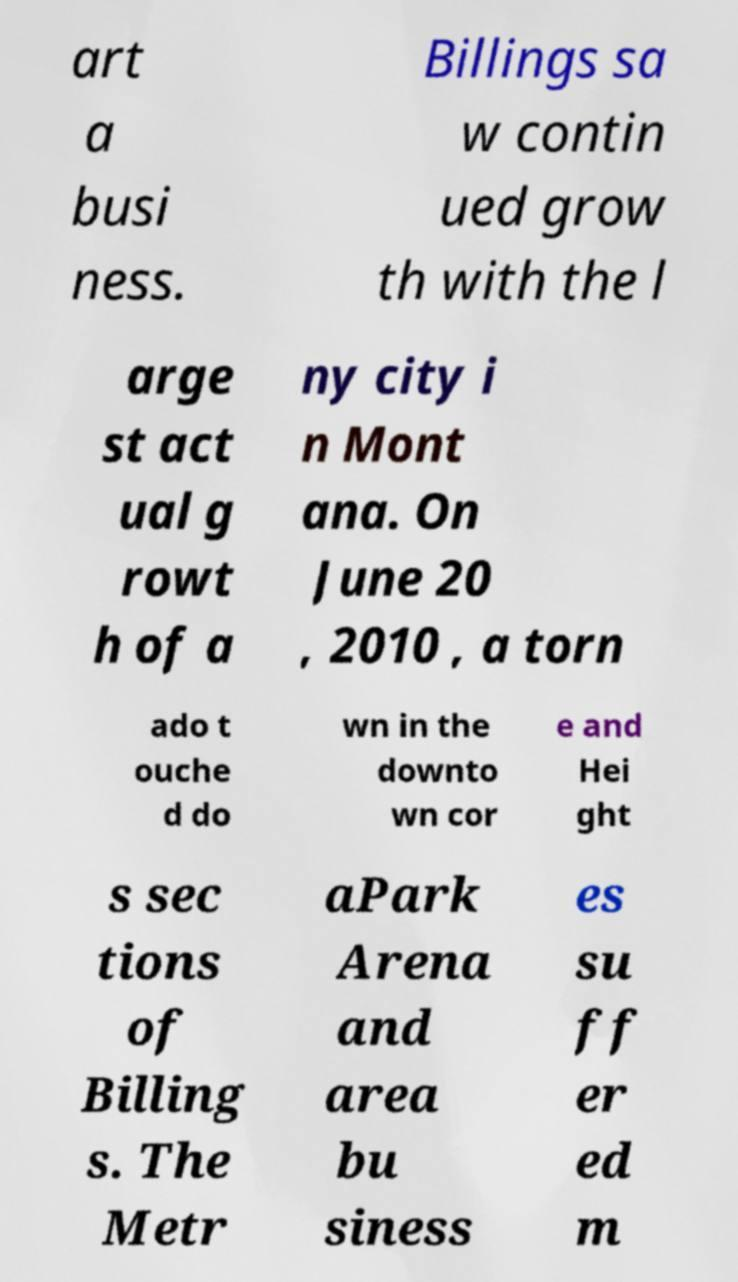Can you read and provide the text displayed in the image?This photo seems to have some interesting text. Can you extract and type it out for me? art a busi ness. Billings sa w contin ued grow th with the l arge st act ual g rowt h of a ny city i n Mont ana. On June 20 , 2010 , a torn ado t ouche d do wn in the downto wn cor e and Hei ght s sec tions of Billing s. The Metr aPark Arena and area bu siness es su ff er ed m 